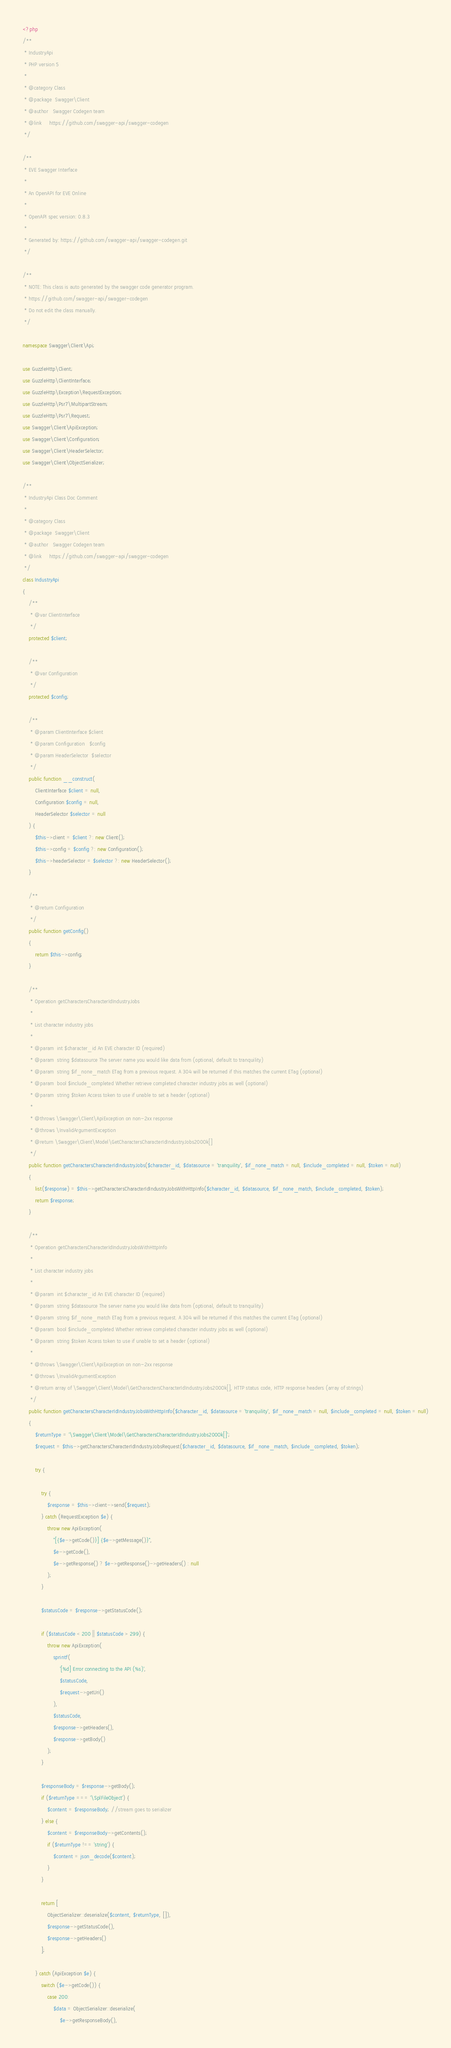Convert code to text. <code><loc_0><loc_0><loc_500><loc_500><_PHP_><?php
/**
 * IndustryApi
 * PHP version 5
 *
 * @category Class
 * @package  Swagger\Client
 * @author   Swagger Codegen team
 * @link     https://github.com/swagger-api/swagger-codegen
 */

/**
 * EVE Swagger Interface
 *
 * An OpenAPI for EVE Online
 *
 * OpenAPI spec version: 0.8.3
 * 
 * Generated by: https://github.com/swagger-api/swagger-codegen.git
 */

/**
 * NOTE: This class is auto generated by the swagger code generator program.
 * https://github.com/swagger-api/swagger-codegen
 * Do not edit the class manually.
 */

namespace Swagger\Client\Api;

use GuzzleHttp\Client;
use GuzzleHttp\ClientInterface;
use GuzzleHttp\Exception\RequestException;
use GuzzleHttp\Psr7\MultipartStream;
use GuzzleHttp\Psr7\Request;
use Swagger\Client\ApiException;
use Swagger\Client\Configuration;
use Swagger\Client\HeaderSelector;
use Swagger\Client\ObjectSerializer;

/**
 * IndustryApi Class Doc Comment
 *
 * @category Class
 * @package  Swagger\Client
 * @author   Swagger Codegen team
 * @link     https://github.com/swagger-api/swagger-codegen
 */
class IndustryApi
{
    /**
     * @var ClientInterface
     */
    protected $client;

    /**
     * @var Configuration
     */
    protected $config;

    /**
     * @param ClientInterface $client
     * @param Configuration   $config
     * @param HeaderSelector  $selector
     */
    public function __construct(
        ClientInterface $client = null,
        Configuration $config = null,
        HeaderSelector $selector = null
    ) {
        $this->client = $client ?: new Client();
        $this->config = $config ?: new Configuration();
        $this->headerSelector = $selector ?: new HeaderSelector();
    }

    /**
     * @return Configuration
     */
    public function getConfig()
    {
        return $this->config;
    }

    /**
     * Operation getCharactersCharacterIdIndustryJobs
     *
     * List character industry jobs
     *
     * @param  int $character_id An EVE character ID (required)
     * @param  string $datasource The server name you would like data from (optional, default to tranquility)
     * @param  string $if_none_match ETag from a previous request. A 304 will be returned if this matches the current ETag (optional)
     * @param  bool $include_completed Whether retrieve completed character industry jobs as well (optional)
     * @param  string $token Access token to use if unable to set a header (optional)
     *
     * @throws \Swagger\Client\ApiException on non-2xx response
     * @throws \InvalidArgumentException
     * @return \Swagger\Client\Model\GetCharactersCharacterIdIndustryJobs200Ok[]
     */
    public function getCharactersCharacterIdIndustryJobs($character_id, $datasource = 'tranquility', $if_none_match = null, $include_completed = null, $token = null)
    {
        list($response) = $this->getCharactersCharacterIdIndustryJobsWithHttpInfo($character_id, $datasource, $if_none_match, $include_completed, $token);
        return $response;
    }

    /**
     * Operation getCharactersCharacterIdIndustryJobsWithHttpInfo
     *
     * List character industry jobs
     *
     * @param  int $character_id An EVE character ID (required)
     * @param  string $datasource The server name you would like data from (optional, default to tranquility)
     * @param  string $if_none_match ETag from a previous request. A 304 will be returned if this matches the current ETag (optional)
     * @param  bool $include_completed Whether retrieve completed character industry jobs as well (optional)
     * @param  string $token Access token to use if unable to set a header (optional)
     *
     * @throws \Swagger\Client\ApiException on non-2xx response
     * @throws \InvalidArgumentException
     * @return array of \Swagger\Client\Model\GetCharactersCharacterIdIndustryJobs200Ok[], HTTP status code, HTTP response headers (array of strings)
     */
    public function getCharactersCharacterIdIndustryJobsWithHttpInfo($character_id, $datasource = 'tranquility', $if_none_match = null, $include_completed = null, $token = null)
    {
        $returnType = '\Swagger\Client\Model\GetCharactersCharacterIdIndustryJobs200Ok[]';
        $request = $this->getCharactersCharacterIdIndustryJobsRequest($character_id, $datasource, $if_none_match, $include_completed, $token);

        try {

            try {
                $response = $this->client->send($request);
            } catch (RequestException $e) {
                throw new ApiException(
                    "[{$e->getCode()}] {$e->getMessage()}",
                    $e->getCode(),
                    $e->getResponse() ? $e->getResponse()->getHeaders() : null
                );
            }

            $statusCode = $response->getStatusCode();

            if ($statusCode < 200 || $statusCode > 299) {
                throw new ApiException(
                    sprintf(
                        '[%d] Error connecting to the API (%s)',
                        $statusCode,
                        $request->getUri()
                    ),
                    $statusCode,
                    $response->getHeaders(),
                    $response->getBody()
                );
            }

            $responseBody = $response->getBody();
            if ($returnType === '\SplFileObject') {
                $content = $responseBody; //stream goes to serializer
            } else {
                $content = $responseBody->getContents();
                if ($returnType !== 'string') {
                    $content = json_decode($content);
                }
            }

            return [
                ObjectSerializer::deserialize($content, $returnType, []),
                $response->getStatusCode(),
                $response->getHeaders()
            ];

        } catch (ApiException $e) {
            switch ($e->getCode()) {
                case 200:
                    $data = ObjectSerializer::deserialize(
                        $e->getResponseBody(),</code> 